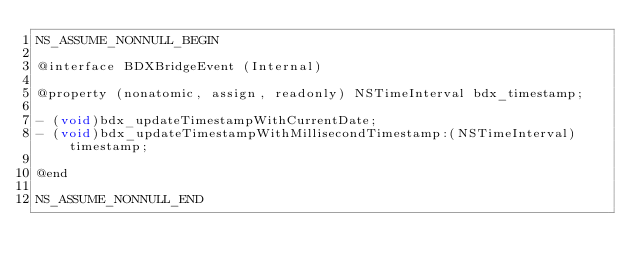Convert code to text. <code><loc_0><loc_0><loc_500><loc_500><_C_>NS_ASSUME_NONNULL_BEGIN

@interface BDXBridgeEvent (Internal)

@property (nonatomic, assign, readonly) NSTimeInterval bdx_timestamp;

- (void)bdx_updateTimestampWithCurrentDate;
- (void)bdx_updateTimestampWithMillisecondTimestamp:(NSTimeInterval)timestamp;

@end

NS_ASSUME_NONNULL_END
</code> 